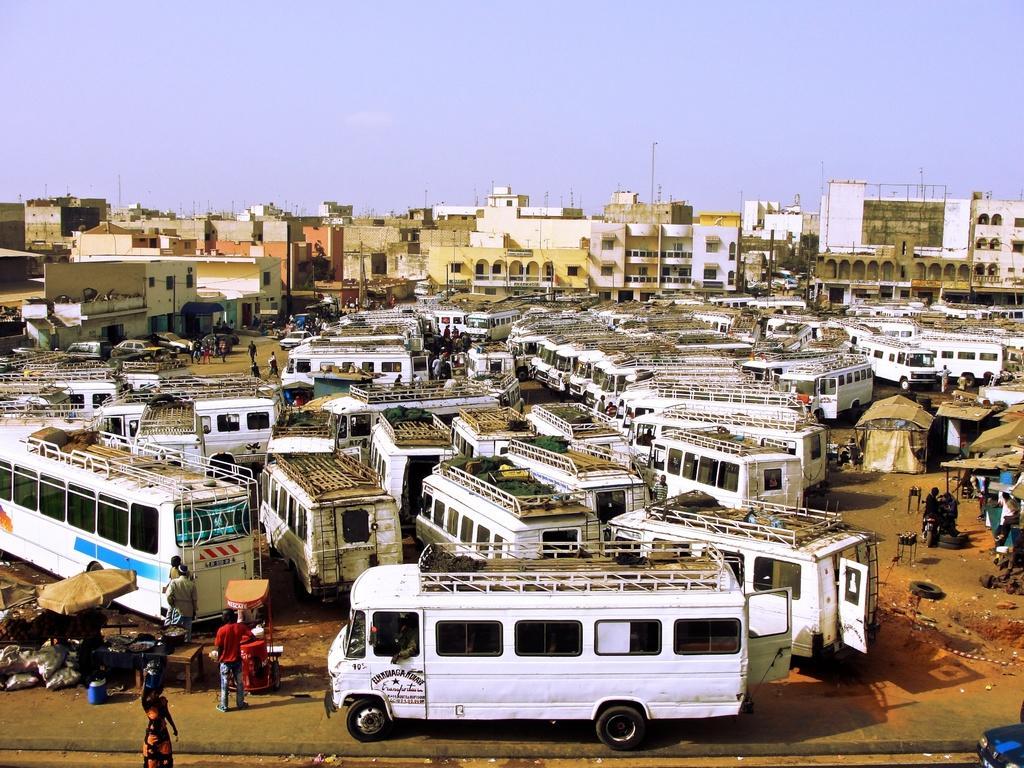Please provide a concise description of this image. This image consists of many buses in white color are parked in a ground. In the background, there are many buildings. At the top, there is a sky. At the bottom, there is a road. 